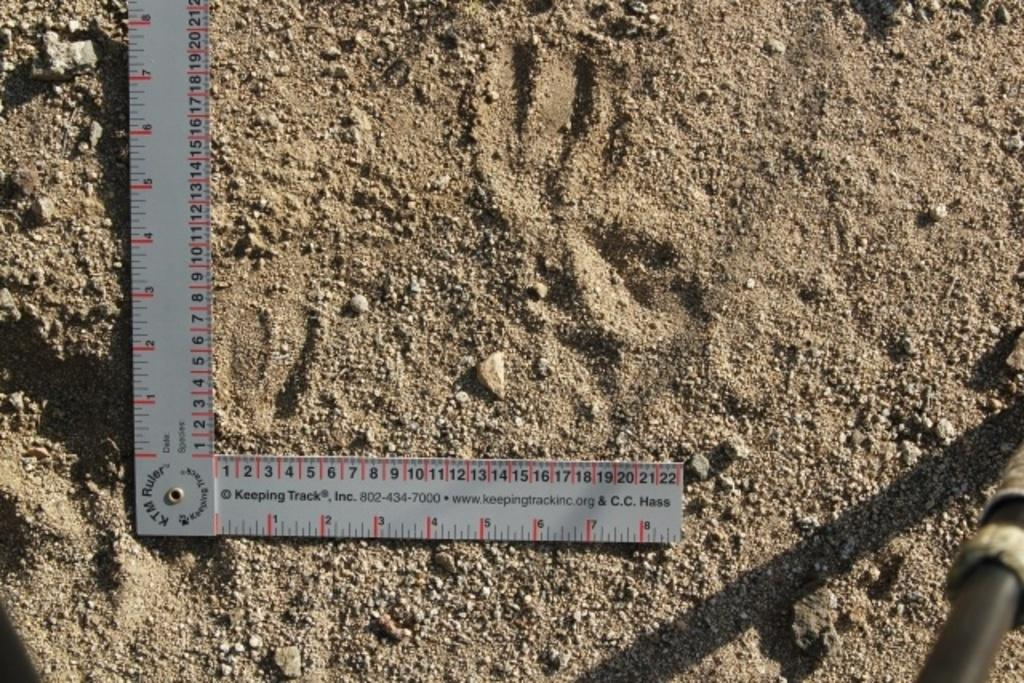<image>
Summarize the visual content of the image. A K.T.M. branded L-shaped ruler sits on coarse sand. 